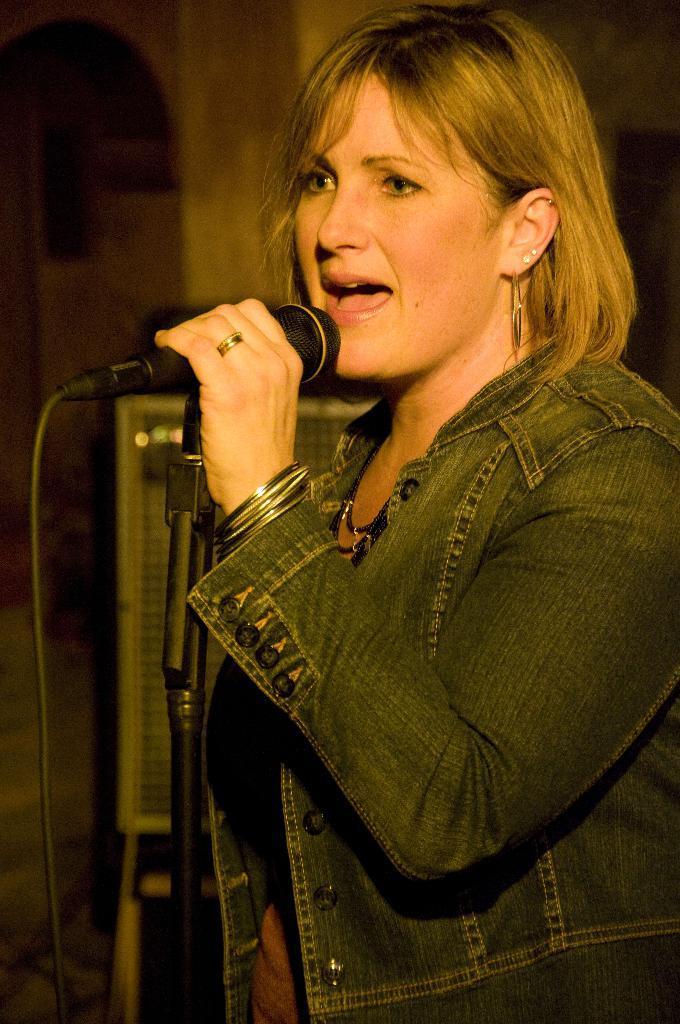Please provide a concise description of this image. In this picture I can see there is a woman standing and she is holding a microphone and she is singing. The woman is looking at the left side and there is an object in the backdrop and it is blurred. 